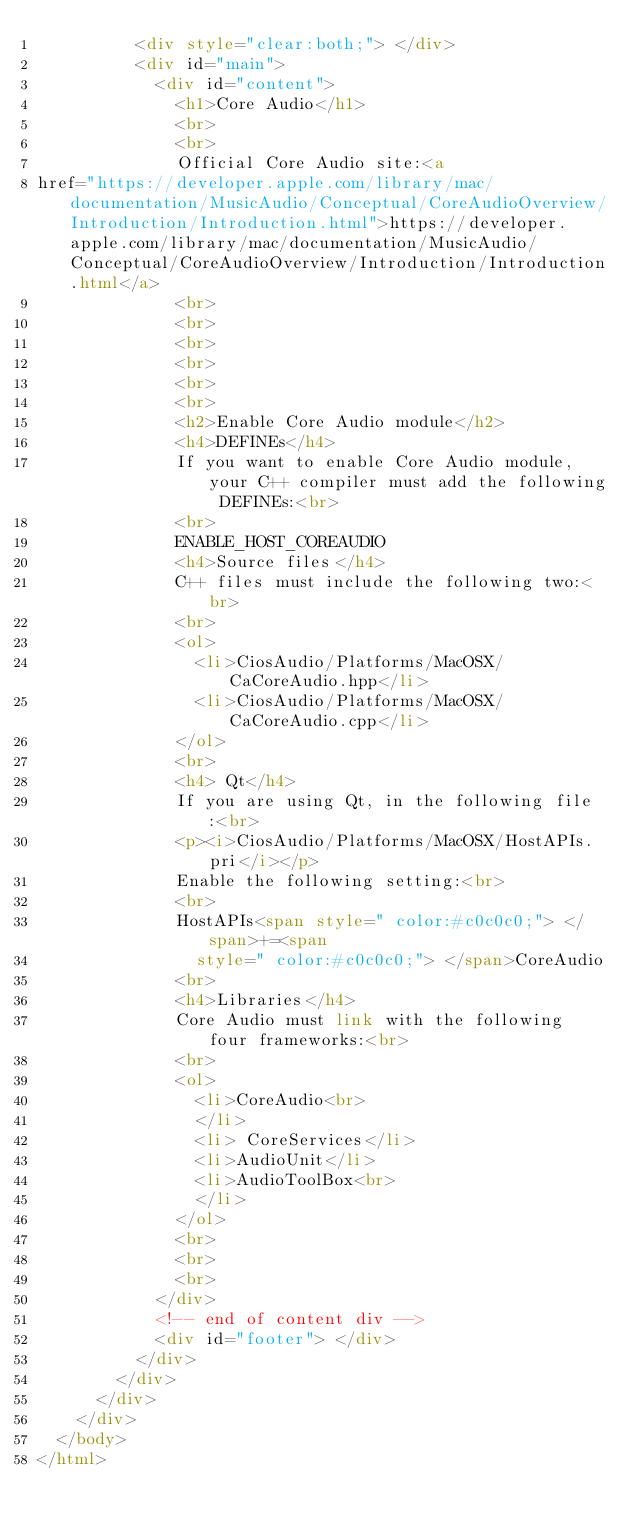<code> <loc_0><loc_0><loc_500><loc_500><_HTML_>          <div style="clear:both;"> </div>
          <div id="main">
            <div id="content">
              <h1>Core Audio</h1>
              <br>
              <br>
              Official Core Audio site:<a
href="https://developer.apple.com/library/mac/documentation/MusicAudio/Conceptual/CoreAudioOverview/Introduction/Introduction.html">https://developer.apple.com/library/mac/documentation/MusicAudio/Conceptual/CoreAudioOverview/Introduction/Introduction.html</a>
              <br>
              <br>
              <br>
              <br>
              <br>
              <br>
              <h2>Enable Core Audio module</h2>
              <h4>DEFINEs</h4>
              If you want to enable Core Audio module, your C++ compiler must add the following DEFINEs:<br>
              <br>
              ENABLE_HOST_COREAUDIO
              <h4>Source files</h4>
              C++ files must include the following two:<br>
              <br>
              <ol>
                <li>CiosAudio/Platforms/MacOSX/CaCoreAudio.hpp</li>
                <li>CiosAudio/Platforms/MacOSX/CaCoreAudio.cpp</li>
              </ol>
              <br>
              <h4> Qt</h4>
              If you are using Qt, in the following file:<br>
              <p><i>CiosAudio/Platforms/MacOSX/HostAPIs.pri</i></p>
              Enable the following setting:<br>
              <br>
              HostAPIs<span style=" color:#c0c0c0;"> </span>+=<span
                style=" color:#c0c0c0;"> </span>CoreAudio
              <br>
              <h4>Libraries</h4>
              Core Audio must link with the following four frameworks:<br>
              <br>
              <ol>
                <li>CoreAudio<br>
                </li>
                <li> CoreServices</li>
                <li>AudioUnit</li>
                <li>AudioToolBox<br>
                </li>
              </ol>
              <br>
              <br>
              <br>
            </div>
            <!-- end of content div -->
            <div id="footer"> </div>
          </div>
        </div>
      </div>
    </div>
  </body>
</html>
</code> 